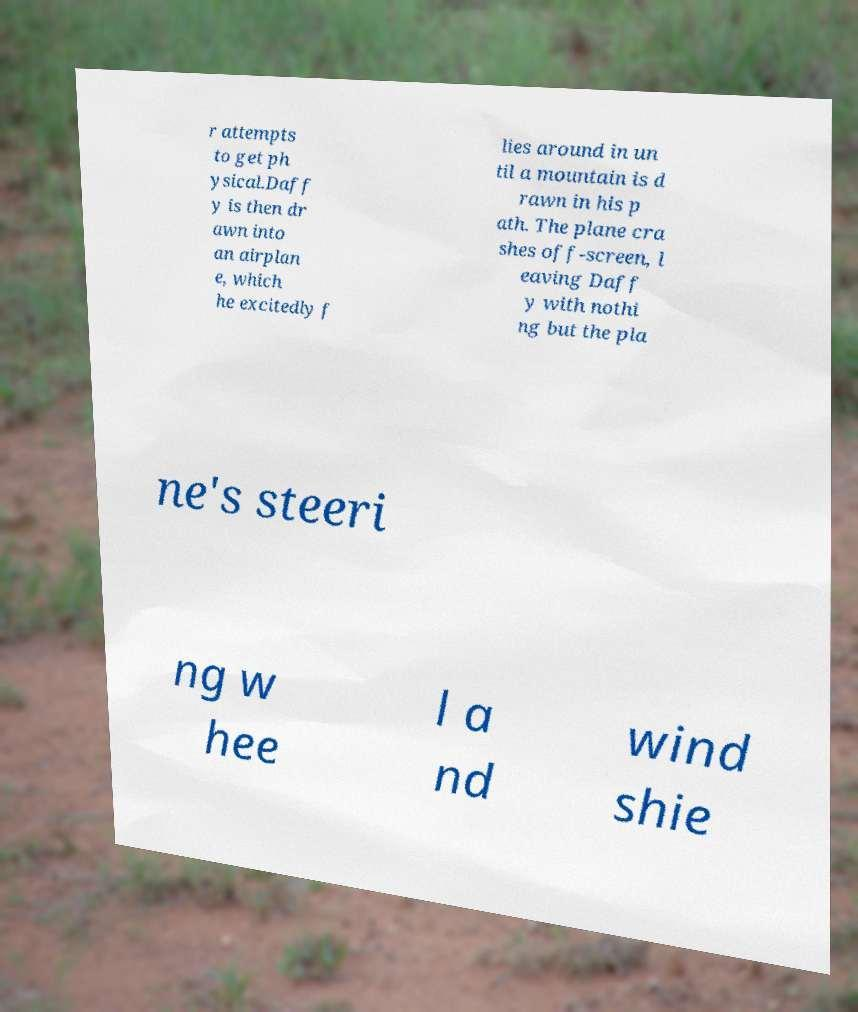Please identify and transcribe the text found in this image. r attempts to get ph ysical.Daff y is then dr awn into an airplan e, which he excitedly f lies around in un til a mountain is d rawn in his p ath. The plane cra shes off-screen, l eaving Daff y with nothi ng but the pla ne's steeri ng w hee l a nd wind shie 